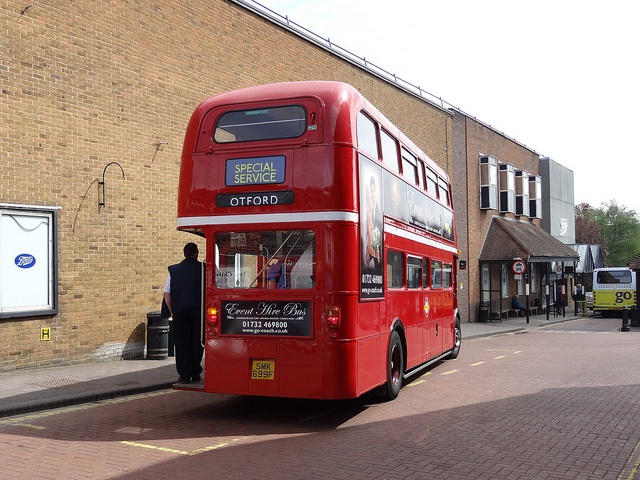Describe the objects in this image and their specific colors. I can see bus in tan, maroon, black, brown, and lightgray tones, people in tan, black, gray, darkgray, and maroon tones, bus in tan, black, olive, gray, and darkgray tones, and people in tan, black, navy, and gray tones in this image. 